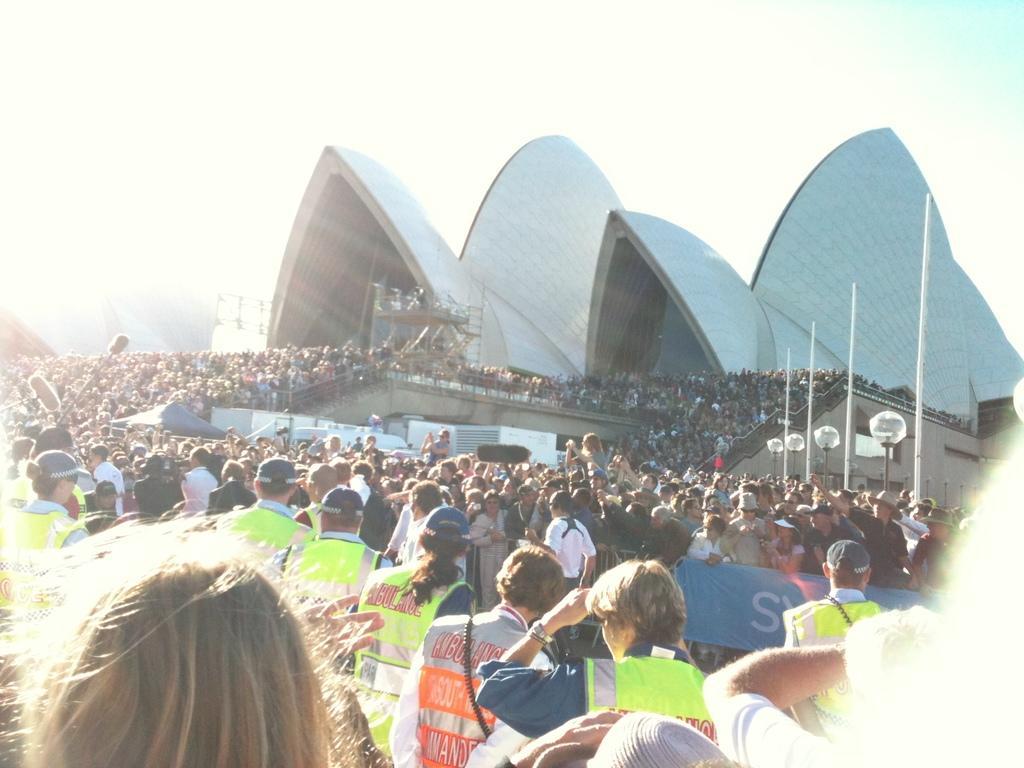How would you summarize this image in a sentence or two? On the bottom of the image we can see security persons. On the background we can see crowd who are standing on the stadium. Here we can see a building. On the right we can see poles and lights. On the top we can see sky and clouds. On the left we can see mice and some peoples are holding camera and mobile phones. On the bottom right there is a banner. 